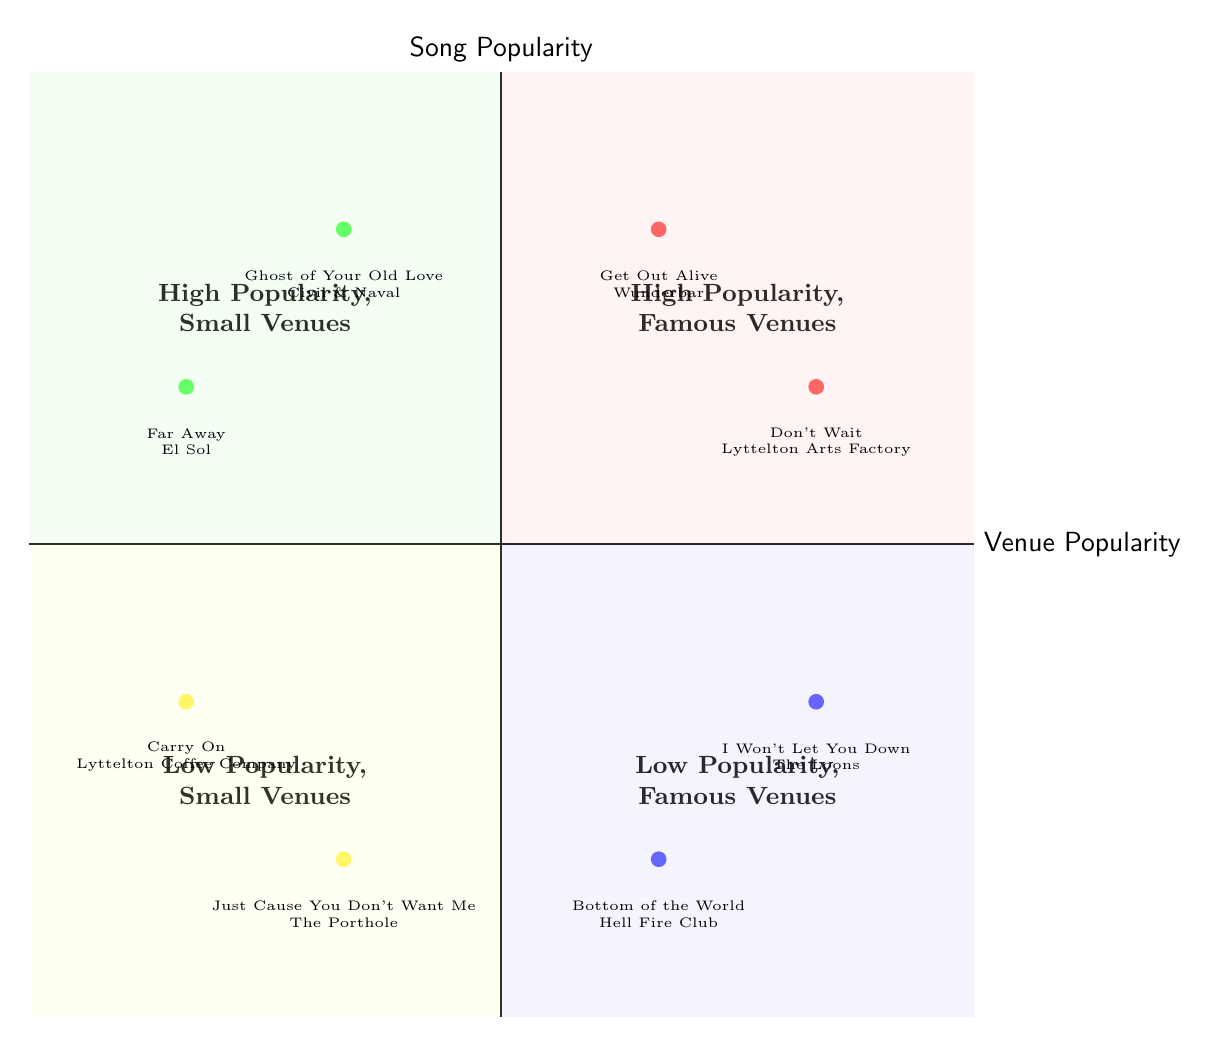What songs are associated with famous venues in high popularity? In the quadrant titled "High Popularity, Famous Venues," the diagram lists two songs: "Get Out Alive" and "Don't Wait." These songs are highlighted in this specific section of the diagram, indicating their association with famous venues where their popularity is recognized.
Answer: Get Out Alive, Don't Wait Which song is linked to the Lyttelton Arts Factory? The diagram indicates that "Don't Wait" is associated with the Lyttelton Arts Factory, as it is mentioned in the "High Popularity, Famous Venues" quadrant under that specific venue label.
Answer: Don't Wait How many songs are categorized as low popularity in small venues? The "Low Popularity, Small Venues" quadrant contains two songs: "Just Cause You Don't Want Me" and "Carry On." When counting the elements in this quadrant, we find there are a total of two songs listed.
Answer: 2 Which song has high popularity but is performed at a small venue? Referring to the "High Popularity, Small Venues" quadrant, the songs listed are "Ghost of Your Old Love" and "Far Away." Both have high popularity, yet they are performed in smaller venues, distinguishing them in the chart.
Answer: Ghost of Your Old Love, Far Away What is the venue for the song "Carry On"? According to the "Low Popularity, Small Venues" quadrant of the diagram, "Carry On" is associated with the Lyttelton Coffee Company. This is explicitly shown in the listings of that segment of the diagram.
Answer: Lyttelton Coffee Company Which quadrant contains the song "Bottom of the World"? The song "Bottom of the World" is found in the "Low Popularity, Famous Venues" quadrant, thus categorizing it under songs that are not as popular but are associated with well-known venues.
Answer: Low Popularity, Famous Venues How many songs are performing at Civil & Naval? The "High Popularity, Small Venues" quadrant lists only one song associated with Civil & Naval, which is "Ghost of Your Old Love." This indicates that among the songs listed, only one performs at this particular venue.
Answer: 1 What is the relationship between song popularity and the venue Hell Fire Club? Hell Fire Club is located in the "Low Popularity, Famous Venues" quadrant, where it is associated with the song "Bottom of the World." This denotes that the song does not have high popularity but is performed in a famous venue.
Answer: Low popularity, famous venue Which quadrant has songs related to small venues? The diagram displays two quadrants concerning songs related to small venues: "High Popularity, Small Venues" and "Low Popularity, Small Venues." Each of these quadrants contains songs performed specifically in smaller venue settings.
Answer: High Popularity, Small Venues; Low Popularity, Small Venues 